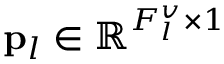Convert formula to latex. <formula><loc_0><loc_0><loc_500><loc_500>{ p } _ { l } \in \mathbb { R } ^ { F _ { l } ^ { v } \times 1 }</formula> 